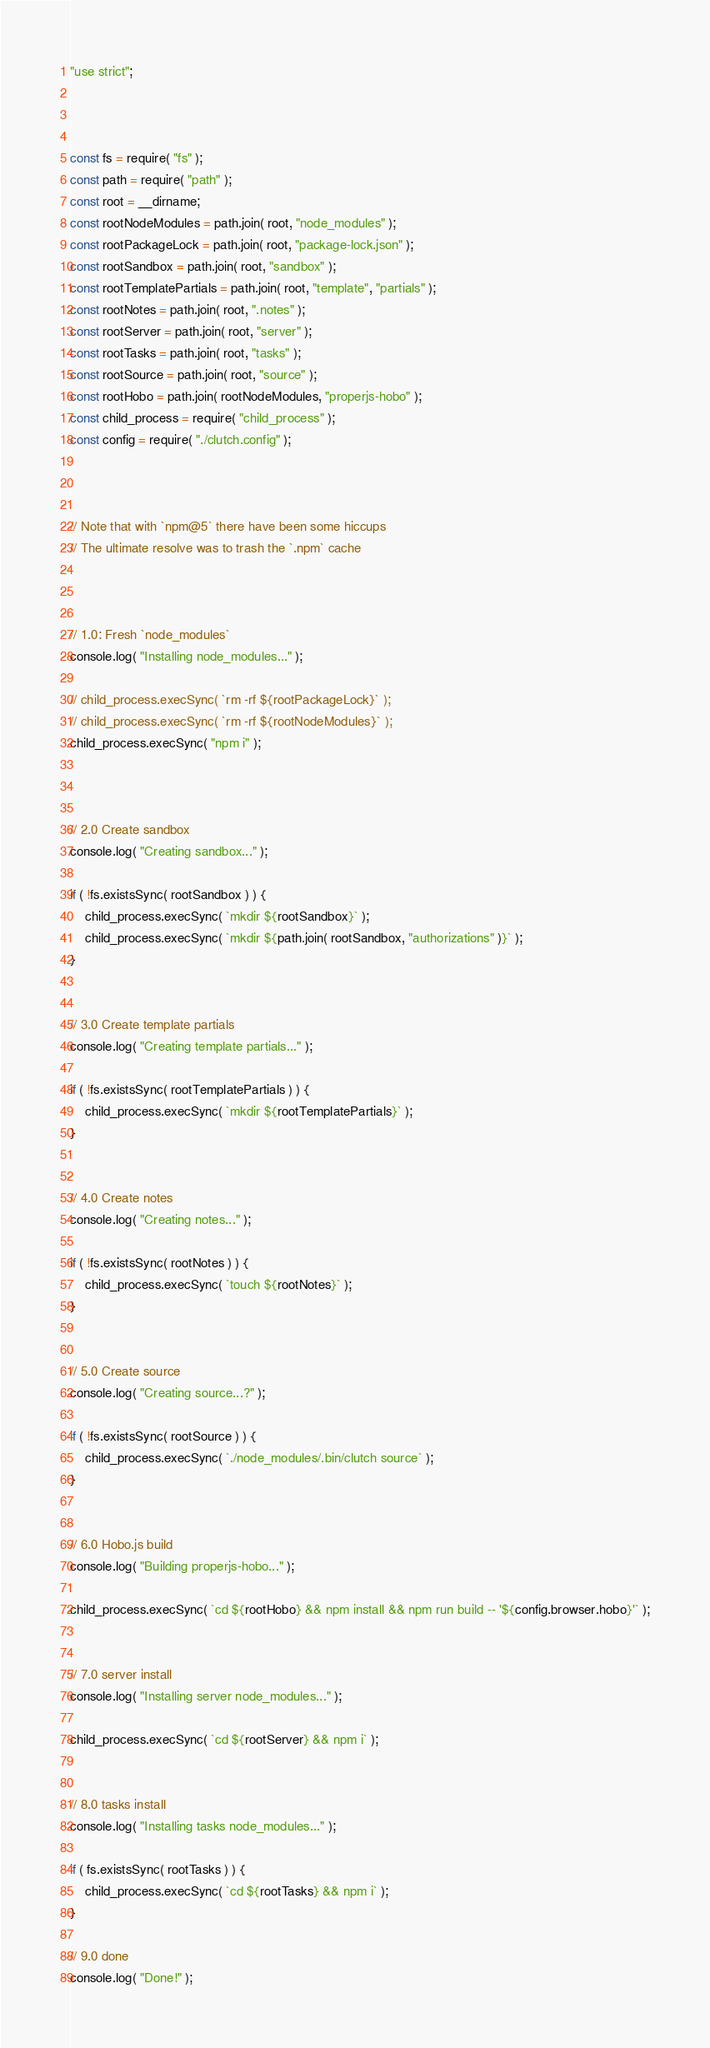<code> <loc_0><loc_0><loc_500><loc_500><_JavaScript_>"use strict";



const fs = require( "fs" );
const path = require( "path" );
const root = __dirname;
const rootNodeModules = path.join( root, "node_modules" );
const rootPackageLock = path.join( root, "package-lock.json" );
const rootSandbox = path.join( root, "sandbox" );
const rootTemplatePartials = path.join( root, "template", "partials" );
const rootNotes = path.join( root, ".notes" );
const rootServer = path.join( root, "server" );
const rootTasks = path.join( root, "tasks" );
const rootSource = path.join( root, "source" );
const rootHobo = path.join( rootNodeModules, "properjs-hobo" );
const child_process = require( "child_process" );
const config = require( "./clutch.config" );



// Note that with `npm@5` there have been some hiccups
// The ultimate resolve was to trash the `.npm` cache



// 1.0: Fresh `node_modules`
console.log( "Installing node_modules..." );

// child_process.execSync( `rm -rf ${rootPackageLock}` );
// child_process.execSync( `rm -rf ${rootNodeModules}` );
child_process.execSync( "npm i" );



// 2.0 Create sandbox
console.log( "Creating sandbox..." );

if ( !fs.existsSync( rootSandbox ) ) {
    child_process.execSync( `mkdir ${rootSandbox}` );
    child_process.execSync( `mkdir ${path.join( rootSandbox, "authorizations" )}` );
}


// 3.0 Create template partials
console.log( "Creating template partials..." );

if ( !fs.existsSync( rootTemplatePartials ) ) {
    child_process.execSync( `mkdir ${rootTemplatePartials}` );
}


// 4.0 Create notes
console.log( "Creating notes..." );

if ( !fs.existsSync( rootNotes ) ) {
    child_process.execSync( `touch ${rootNotes}` );
}


// 5.0 Create source
console.log( "Creating source...?" );

if ( !fs.existsSync( rootSource ) ) {
    child_process.execSync( `./node_modules/.bin/clutch source` );
}


// 6.0 Hobo.js build
console.log( "Building properjs-hobo..." );

child_process.execSync( `cd ${rootHobo} && npm install && npm run build -- '${config.browser.hobo}'` );


// 7.0 server install
console.log( "Installing server node_modules..." );

child_process.execSync( `cd ${rootServer} && npm i` );


// 8.0 tasks install
console.log( "Installing tasks node_modules..." );

if ( fs.existsSync( rootTasks ) ) {
    child_process.execSync( `cd ${rootTasks} && npm i` );
}

// 9.0 done
console.log( "Done!" );
</code> 